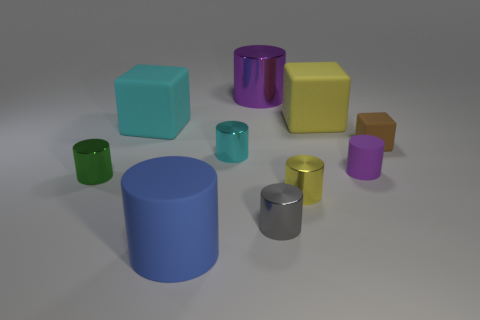How many objects are there in the image, and can you describe their colors? There are ten objects in the image. Starting from the largest, there is a blue cylinder, a large yellow cube, a large purple cylinder, a green cube, a silver cylinder, a yellow cylinder, a brown cube, a purple cube, a small green cylinder, and a small pink cylinder. 